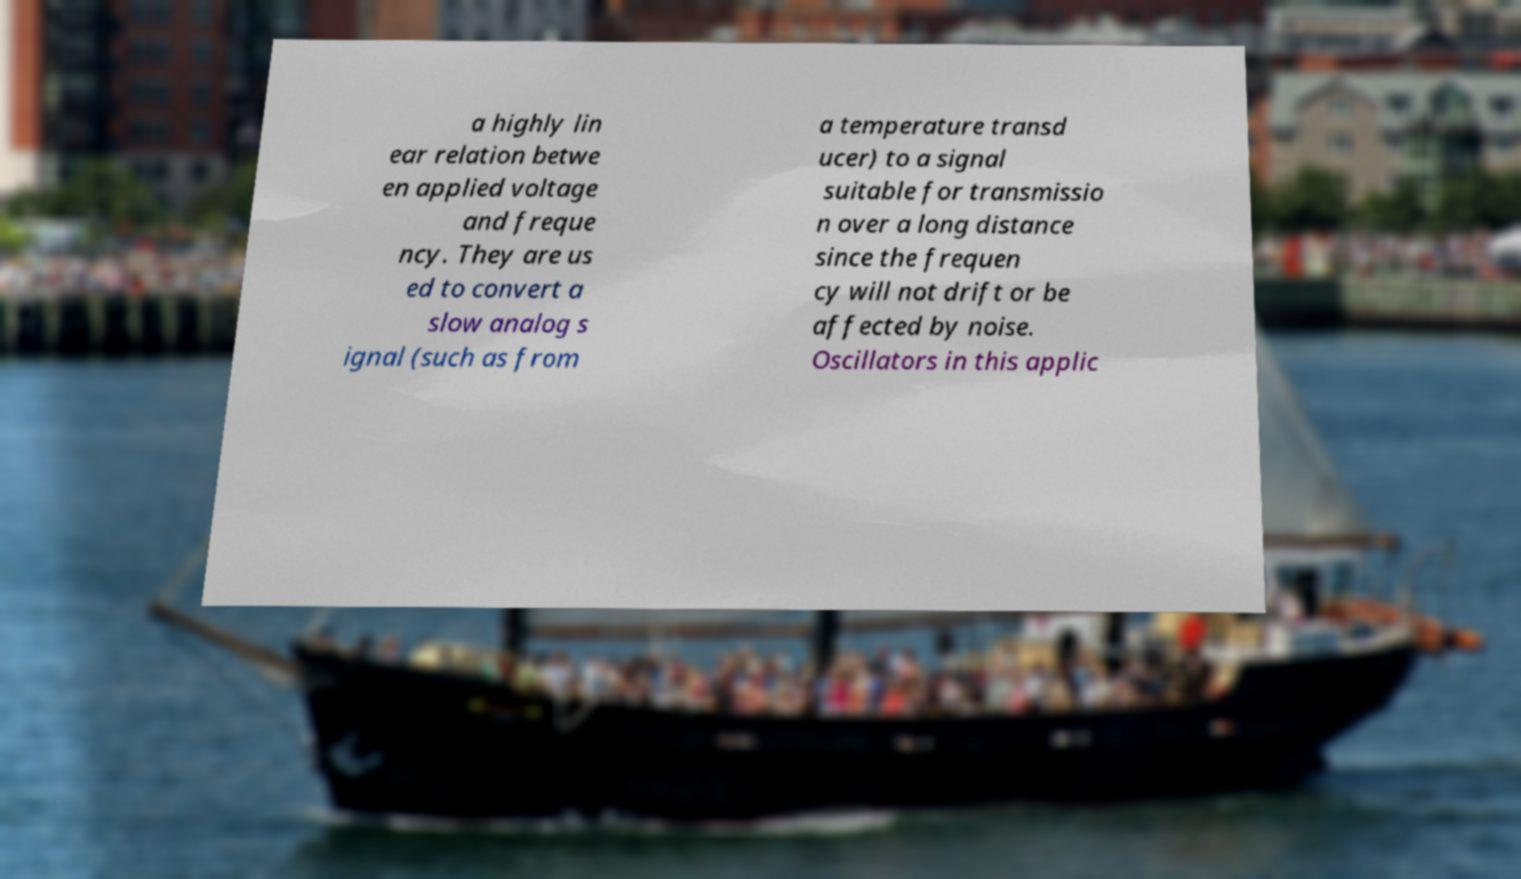I need the written content from this picture converted into text. Can you do that? a highly lin ear relation betwe en applied voltage and freque ncy. They are us ed to convert a slow analog s ignal (such as from a temperature transd ucer) to a signal suitable for transmissio n over a long distance since the frequen cy will not drift or be affected by noise. Oscillators in this applic 